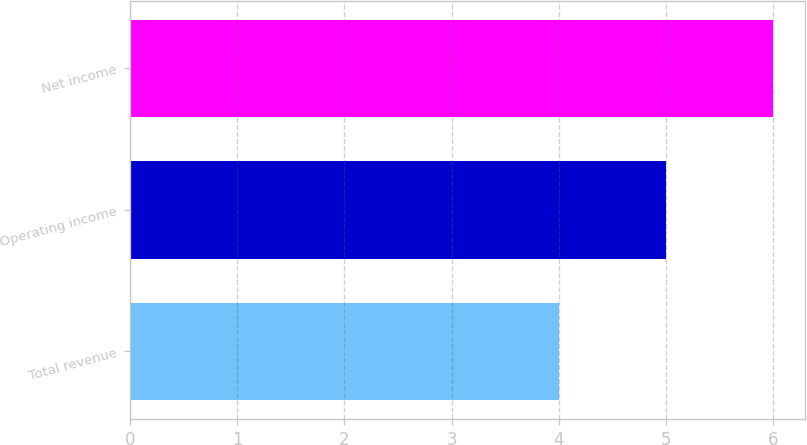<chart> <loc_0><loc_0><loc_500><loc_500><bar_chart><fcel>Total revenue<fcel>Operating income<fcel>Net income<nl><fcel>4<fcel>5<fcel>6<nl></chart> 